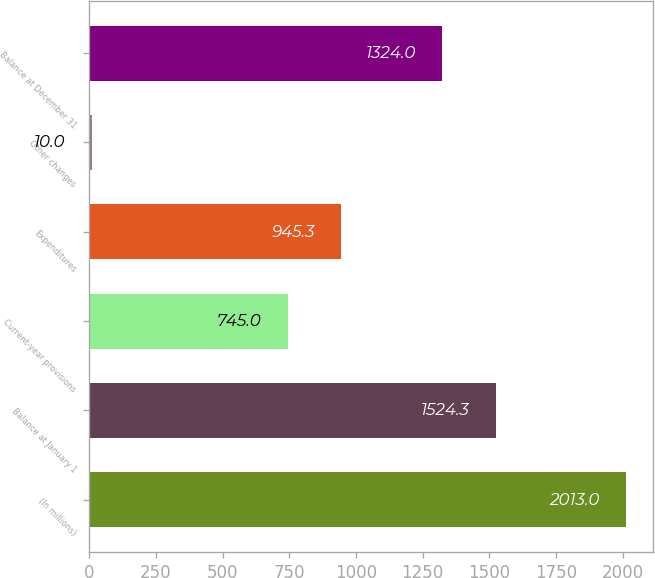Convert chart to OTSL. <chart><loc_0><loc_0><loc_500><loc_500><bar_chart><fcel>(In millions)<fcel>Balance at January 1<fcel>Current-year provisions<fcel>Expenditures<fcel>Other changes<fcel>Balance at December 31<nl><fcel>2013<fcel>1524.3<fcel>745<fcel>945.3<fcel>10<fcel>1324<nl></chart> 